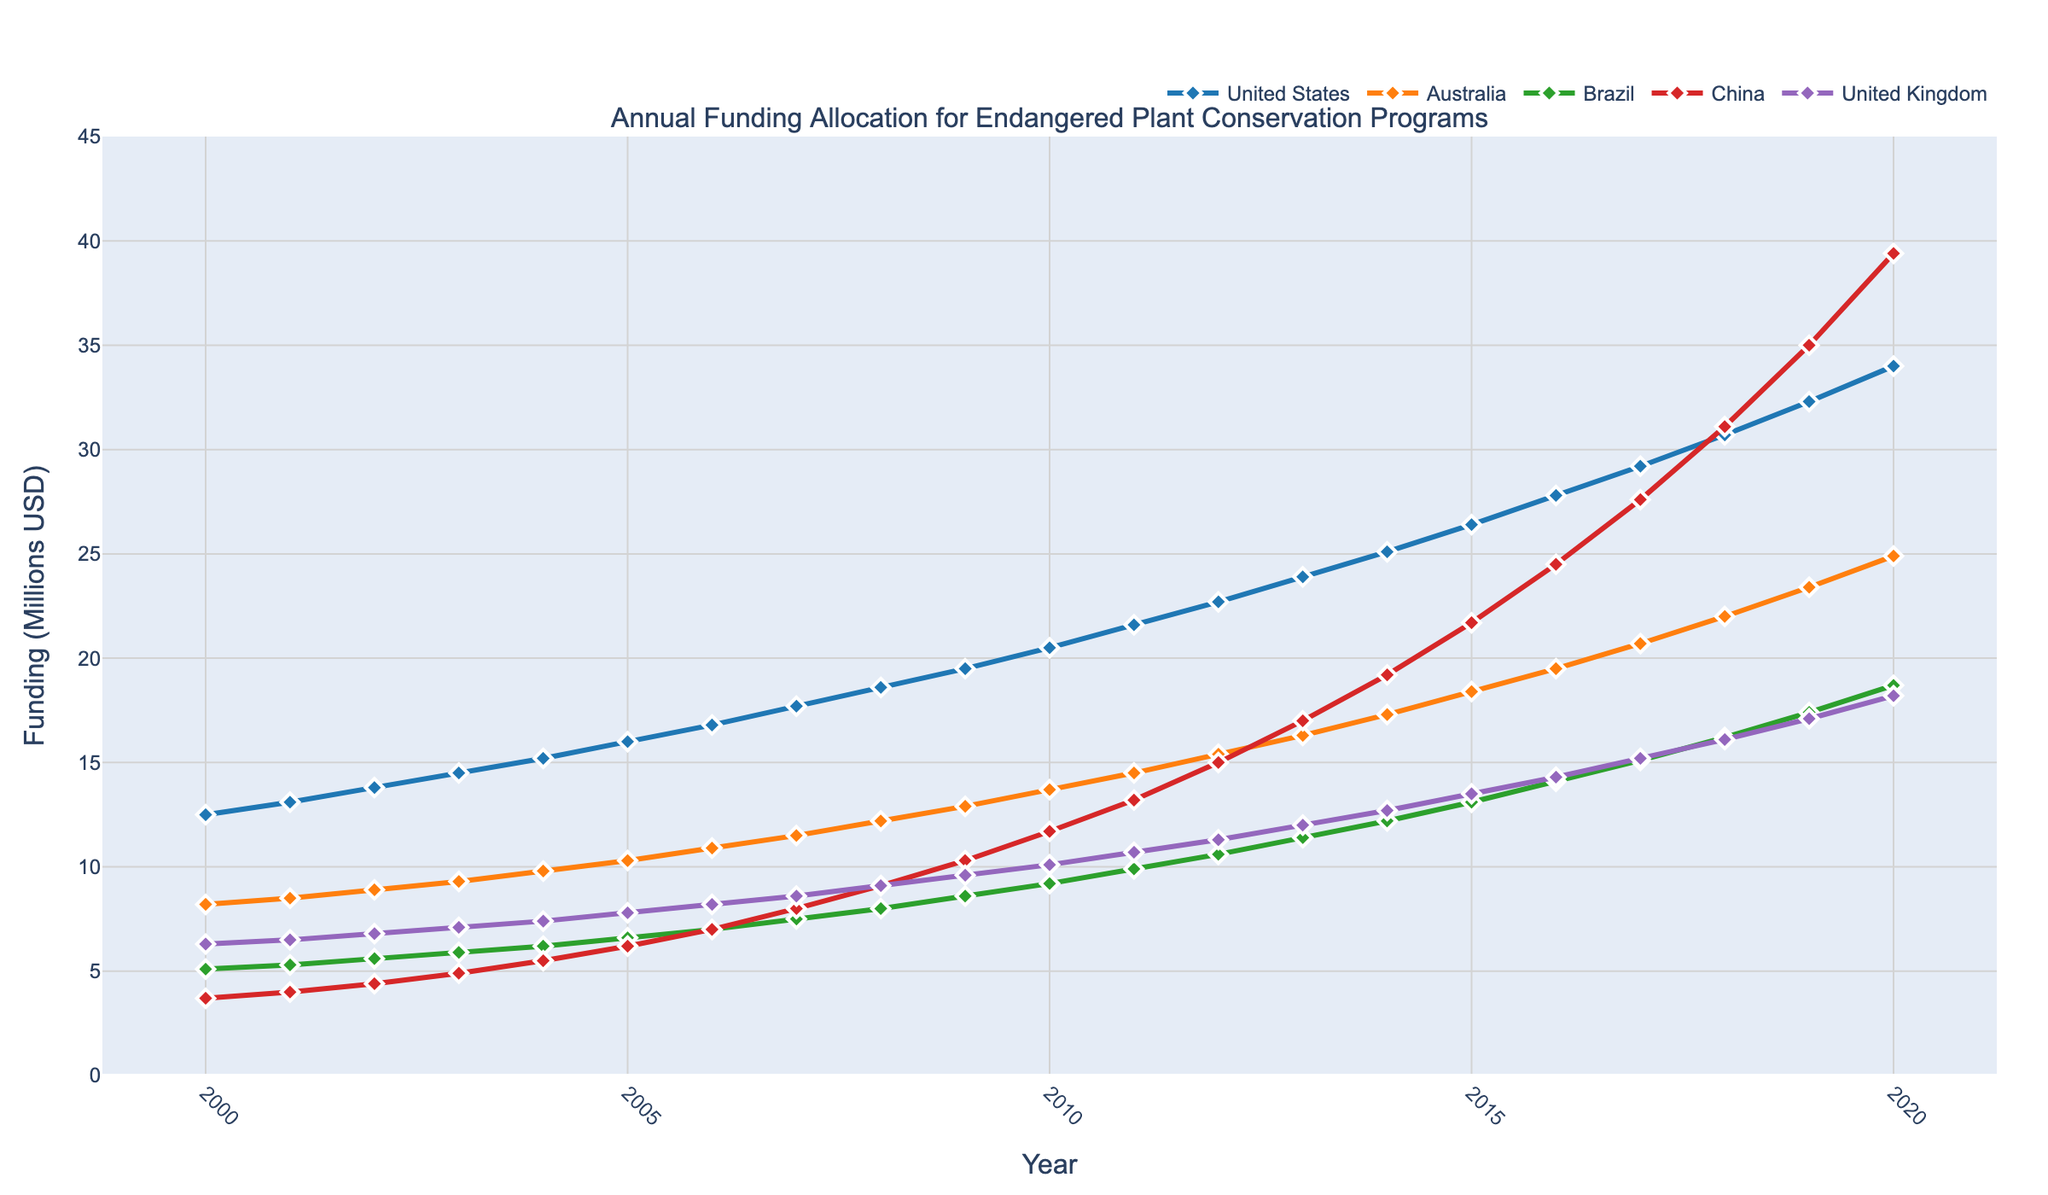How did the funding allocation for the United States change from 2000 to 2020? Identify the initial value for the United States in 2000, which is 12.5 million USD, and the final value in 2020, which is 34.0 million USD. Calculate the difference between these two values: 34.0 - 12.5 = 21.5 million USD
Answer: 21.5 million USD Which country experienced the largest absolute increase in funding from 2000 to 2020? Calculate the absolute increase for each country by subtracting the 2000 value from the 2020 value. For the United States, it is 34.0 - 12.5 = 21.5 million USD; for Australia, it is 24.9 - 8.2 = 16.7 million USD; for Brazil, it is 18.7 - 5.1 = 13.6 million USD; for China, it is 39.4 - 3.7 = 35.7 million USD; and for the United Kingdom, it is 18.2 - 6.3 = 11.9 million USD. China has the largest increase with 35.7 million USD
Answer: China By how much did the funding for Australia exceed that of the United Kingdom in 2015? Identify the funding values for Australia and the United Kingdom in 2015, which are 18.4 million USD and 13.5 million USD respectively. Calculate the difference: 18.4 - 13.5 = 4.9 million USD
Answer: 4.9 million USD Which country had the least funding in 2010, and what was the amount? Examine the funding values for each country in 2010: United States (20.5), Australia (13.7), Brazil (9.2), China (11.7), and United Kingdom (10.1). Identify the smallest value which is for Brazil: 9.2 million USD
Answer: Brazil, 9.2 million USD What is the average funding for China from 2000 to 2020? Sum the funding values for China from all the years and divide by the number of years. The total funding is (3.7 + 4.0 + 4.4 + 4.9 + 5.5 + 6.2 + 7.0 + 8.0 + 9.1 + 10.3 + 11.7 + 13.2 + 15.0 + 17.0 + 19.2 + 21.7 + 24.5 + 27.6 + 31.1 + 35.0 + 39.4) = 319.5 million USD. There are 21 years, so the average is 319.5 / 21 ≈ 15.21 million USD
Answer: 15.21 million USD In which year did the United Kingdom's funding surpass 10 million USD, and by how much? Examine the funding values for each year. The United Kingdom's funding first surpasses 10 million USD in 2010, where it reaches 10.1 million USD, surpassing by 0.1 million USD
Answer: 2010, 0.1 million USD Compare the trend of funding growth for the United States and Brazil from 2000 to 2020. Which country showed a more consistent increase? Examine both trends: The United States shows a steady and consistent growth from 12.5 million USD to 34.0 million USD over the 21 years. Brazil's growth, while increasing, exhibits more fluctuations but generally rises from 5.1 million USD to 18.7 million USD. The United States shows a more consistent increase
Answer: United States 